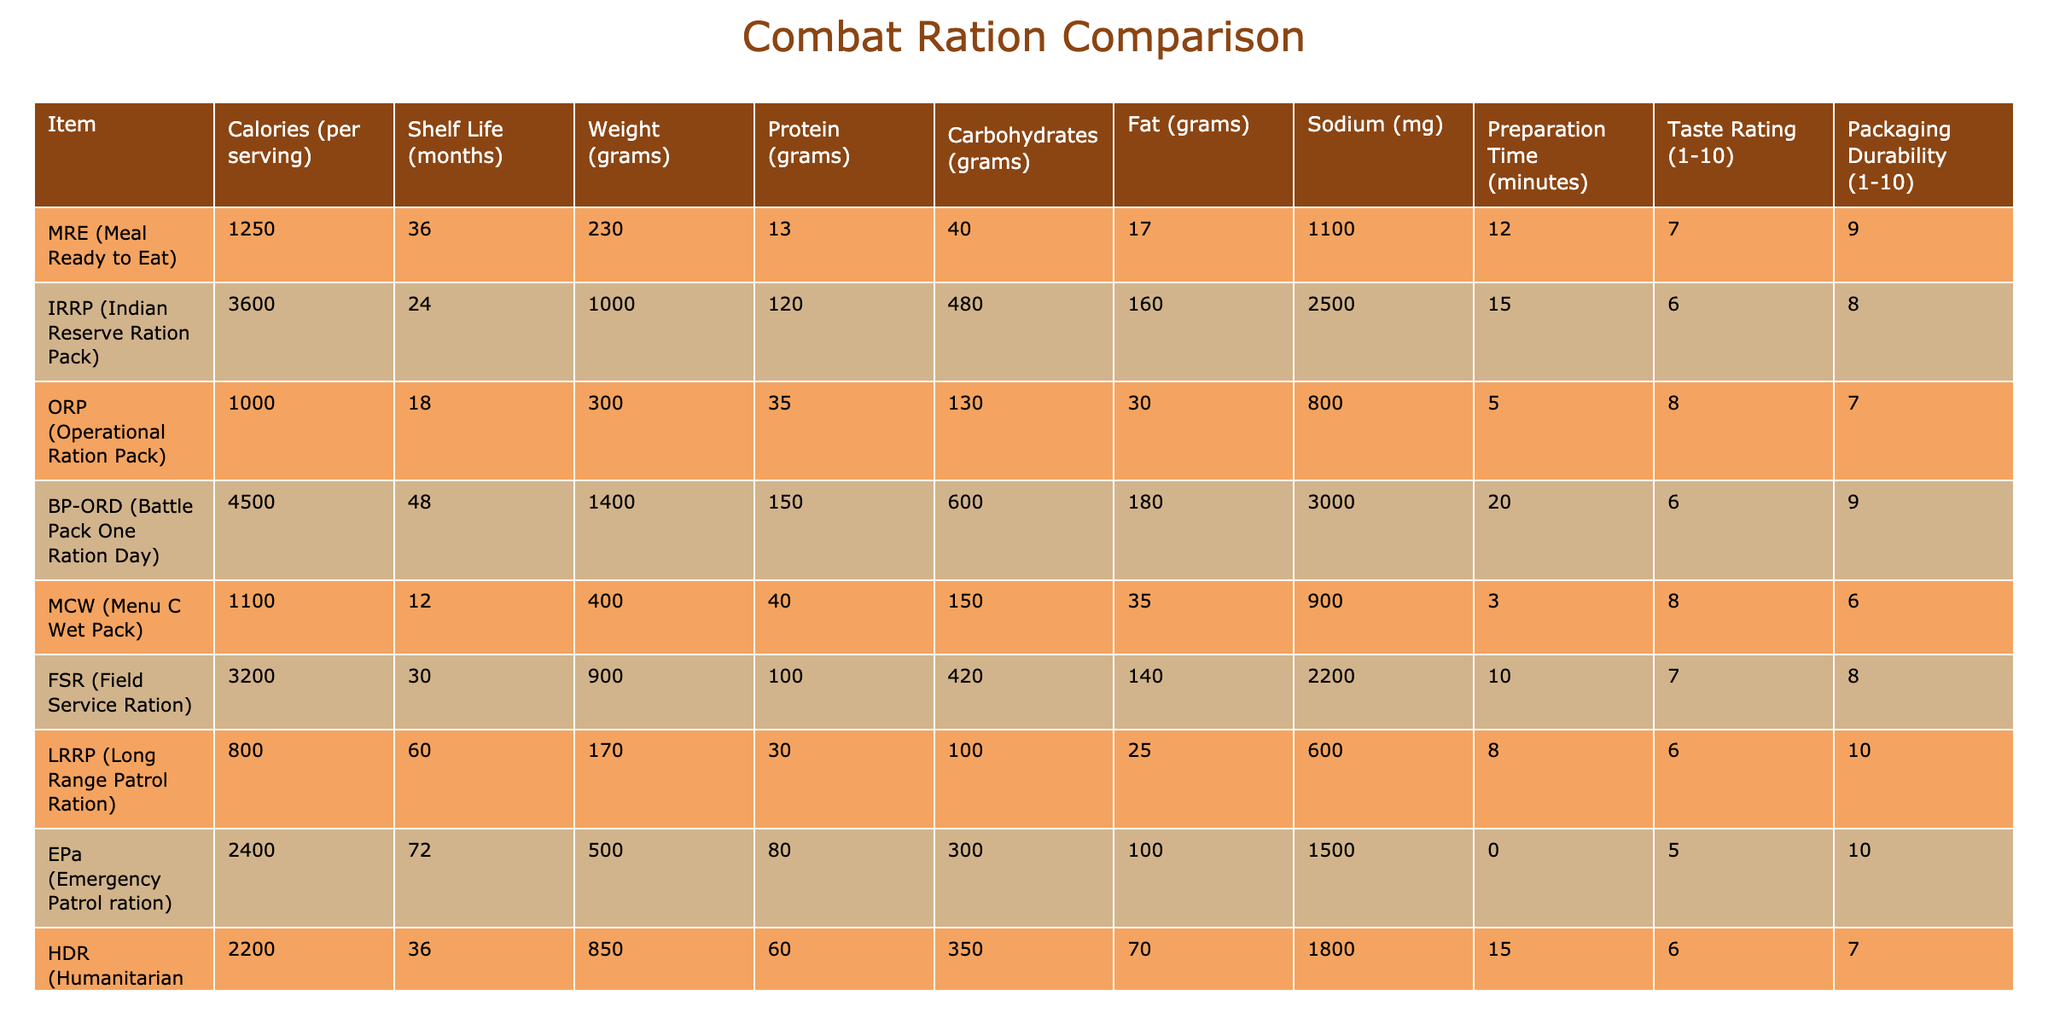What is the shelf life of the ORP? From the table, the shelf life of ORP (Operational Ration Pack) is listed as 18 months.
Answer: 18 months Which combat ration has the highest calories per serving? The table shows that the BP-ORD (Battle Pack One Ration Day) has the highest calories at 4500 per serving, more than any other ration.
Answer: 4500 Are there any rations with a preparation time of less than 5 minutes? By looking through the preparation time column, only the EPa (Emergency Patrol ration) has a preparation time of 0 minutes, which is less than 5 minutes.
Answer: Yes What is the average protein content of the rations? First, sum the protein content: (13 + 120 + 35 + 150 + 40 + 100 + 30 + 80 + 60 + 50) = 678 grams. There are 10 rations, so the average protein content is 678/10 = 67.8 grams.
Answer: 67.8 grams Which ration has the lowest taste rating and what is that rating? The table indicates that the EPa (Emergency Patrol ration) has the lowest taste rating at 5, which is confirmed by looking through the taste rating column.
Answer: 5 Is the IRRP heavier than the FSR? The weight of the IRRP (Indian Reserve Ration Pack) is 1000 grams and the weight of the FSR (Field Service Ration) is 900 grams. Since 1000 is greater than 900, IRRP is indeed heavier.
Answer: Yes What is the total sodium content of the top three rations based on calories? The top three rations based on calories are BP-ORD (3000 mg), IRRP (2500 mg), and FSR (2200 mg). The total sodium is 3000 + 2500 + 2200 = 7700 mg.
Answer: 7700 mg Which ration requires the most weight in grams compared to others? The table indicates that the BP-ORD (Battle Pack One Ration Day) has a weight of 1400 grams, which is greater than the weights of all other rations listed.
Answer: 1400 grams What is the difference in shelf life between the longest and shortest shelf life rations? The longest shelf life is 72 months (EPa) and the shortest is 12 months (MCW). The difference is 72 - 12 = 60 months.
Answer: 60 months 